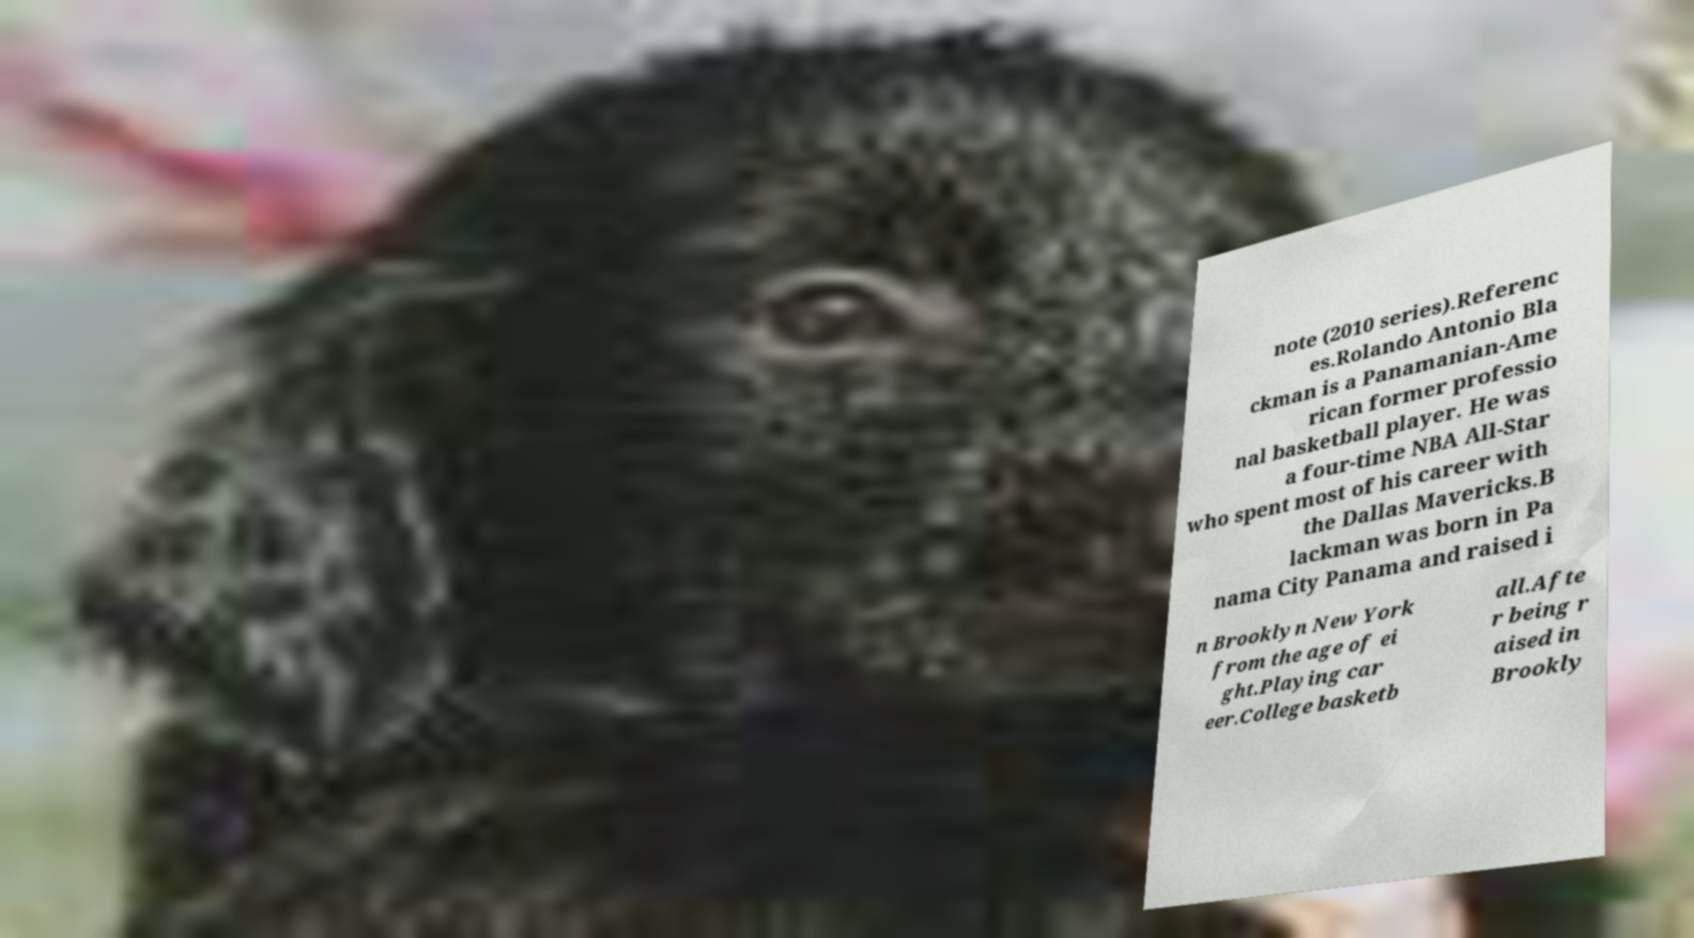Can you accurately transcribe the text from the provided image for me? note (2010 series).Referenc es.Rolando Antonio Bla ckman is a Panamanian-Ame rican former professio nal basketball player. He was a four-time NBA All-Star who spent most of his career with the Dallas Mavericks.B lackman was born in Pa nama City Panama and raised i n Brooklyn New York from the age of ei ght.Playing car eer.College basketb all.Afte r being r aised in Brookly 